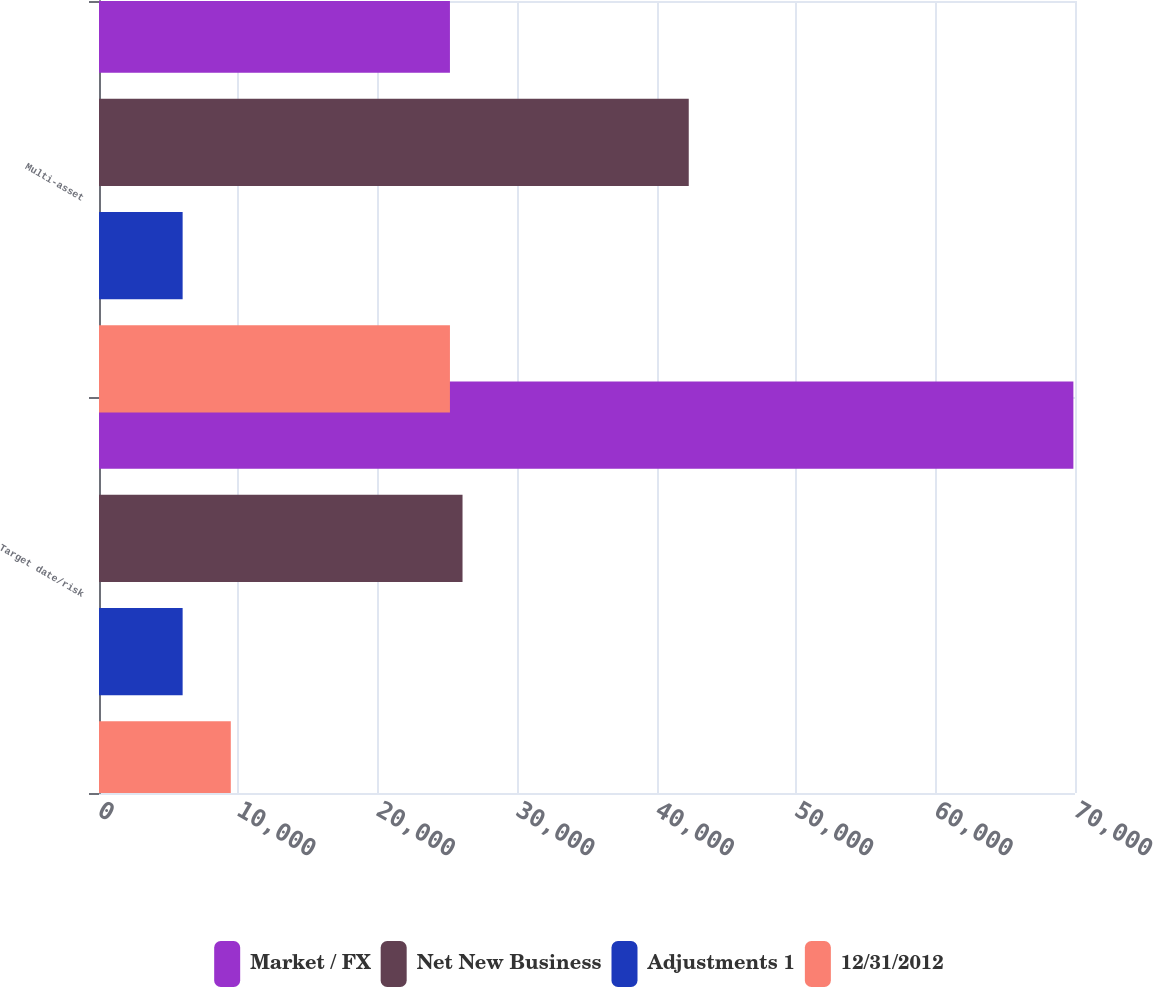Convert chart to OTSL. <chart><loc_0><loc_0><loc_500><loc_500><stacked_bar_chart><ecel><fcel>Target date/risk<fcel>Multi-asset<nl><fcel>Market / FX<fcel>69884<fcel>25170<nl><fcel>Net New Business<fcel>26073<fcel>42298<nl><fcel>Adjustments 1<fcel>5998<fcel>5998<nl><fcel>12/31/2012<fcel>9453<fcel>25170<nl></chart> 